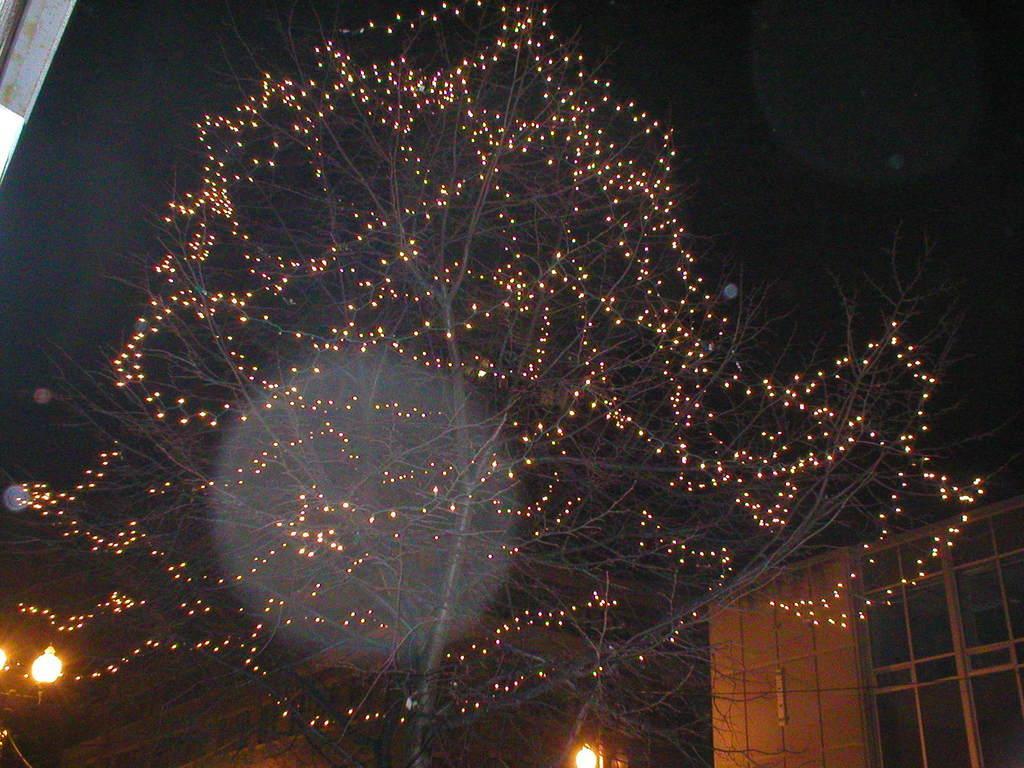How would you summarize this image in a sentence or two? In this image I can see a tree, few lights to the tree, few street lights and few buildings. In the background I can see the dark sky. 